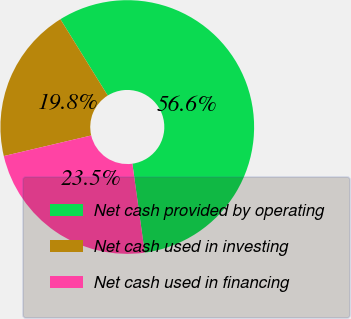Convert chart to OTSL. <chart><loc_0><loc_0><loc_500><loc_500><pie_chart><fcel>Net cash provided by operating<fcel>Net cash used in investing<fcel>Net cash used in financing<nl><fcel>56.64%<fcel>19.84%<fcel>23.52%<nl></chart> 